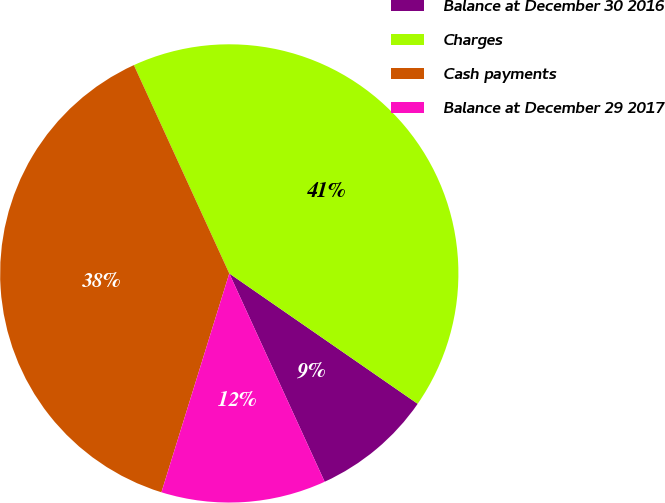Convert chart to OTSL. <chart><loc_0><loc_0><loc_500><loc_500><pie_chart><fcel>Balance at December 30 2016<fcel>Charges<fcel>Cash payments<fcel>Balance at December 29 2017<nl><fcel>8.53%<fcel>41.47%<fcel>38.38%<fcel>11.62%<nl></chart> 